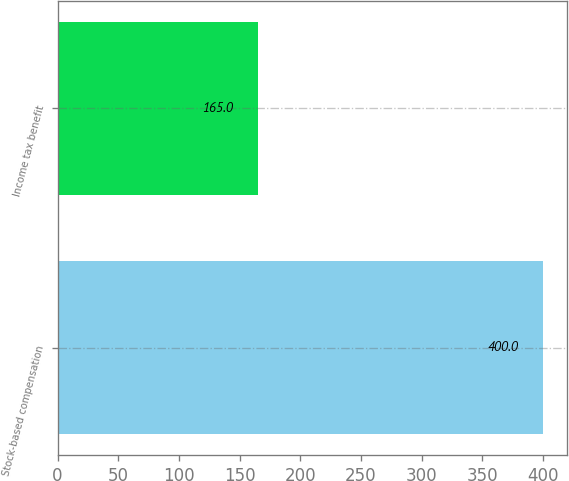Convert chart to OTSL. <chart><loc_0><loc_0><loc_500><loc_500><bar_chart><fcel>Stock-based compensation<fcel>Income tax benefit<nl><fcel>400<fcel>165<nl></chart> 